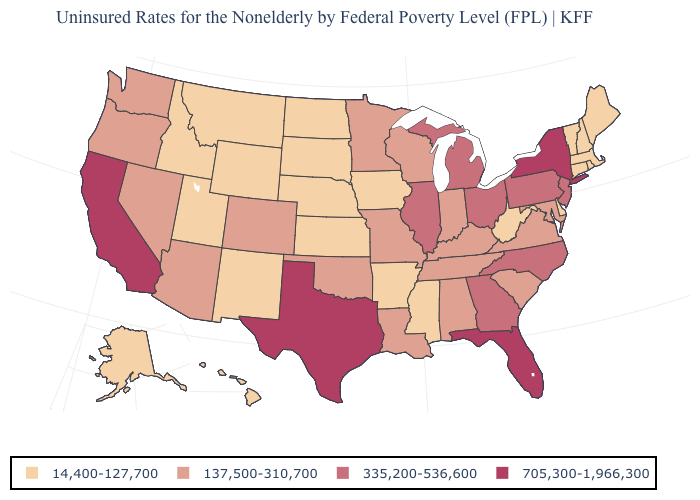How many symbols are there in the legend?
Quick response, please. 4. How many symbols are there in the legend?
Quick response, please. 4. What is the value of Idaho?
Be succinct. 14,400-127,700. What is the value of Ohio?
Keep it brief. 335,200-536,600. Name the states that have a value in the range 705,300-1,966,300?
Short answer required. California, Florida, New York, Texas. What is the value of Oklahoma?
Quick response, please. 137,500-310,700. What is the value of Minnesota?
Quick response, please. 137,500-310,700. What is the value of Florida?
Concise answer only. 705,300-1,966,300. Does the map have missing data?
Short answer required. No. What is the value of Illinois?
Be succinct. 335,200-536,600. Among the states that border Minnesota , which have the highest value?
Keep it brief. Wisconsin. Which states hav the highest value in the MidWest?
Concise answer only. Illinois, Michigan, Ohio. Does Delaware have a lower value than New Hampshire?
Be succinct. No. What is the value of Alaska?
Quick response, please. 14,400-127,700. 